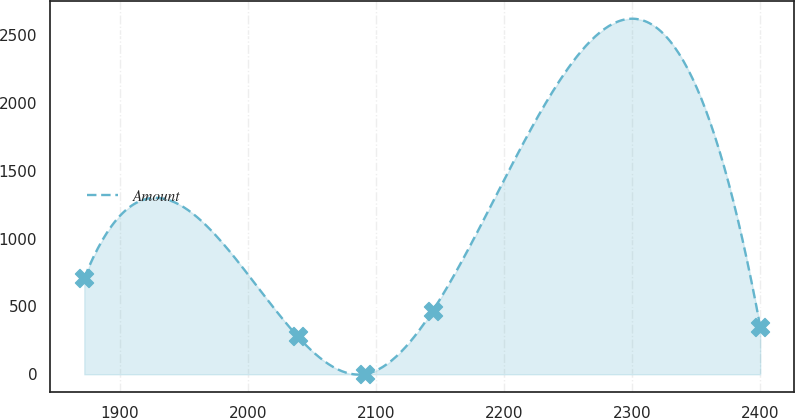<chart> <loc_0><loc_0><loc_500><loc_500><line_chart><ecel><fcel>Amount<nl><fcel>1872.25<fcel>711.07<nl><fcel>2038.72<fcel>280.17<nl><fcel>2091.48<fcel>2.04<nl><fcel>2144.24<fcel>468.44<nl><fcel>2399.89<fcel>351.07<nl></chart> 